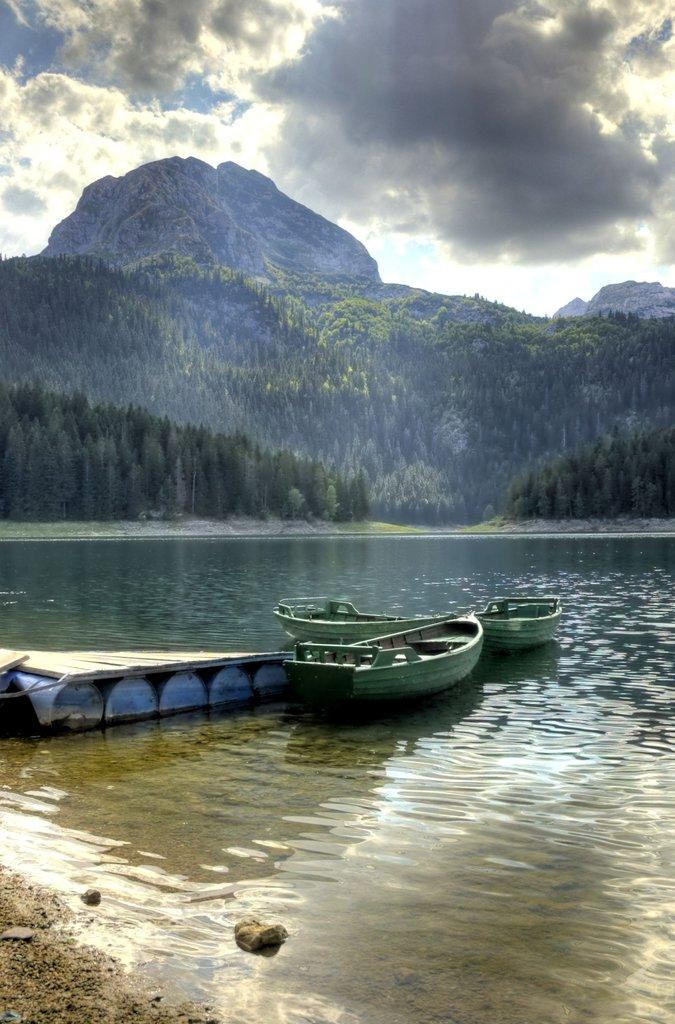What type of vehicles can be seen on the water in the image? There are boats on the water in the image. What type of natural environment is visible in the image? Trees and mountains are present in the image. What is visible in the background of the image? The sky is visible in the background of the image. What can be seen in the sky? Clouds are present in the sky. Are there any spiders visible on the boats in the image? There is no mention of spiders in the image, and they are not visible in the provided facts. What type of poison might be present in the water near the boats? There is no information about any poison in the image or the water near the boats. 